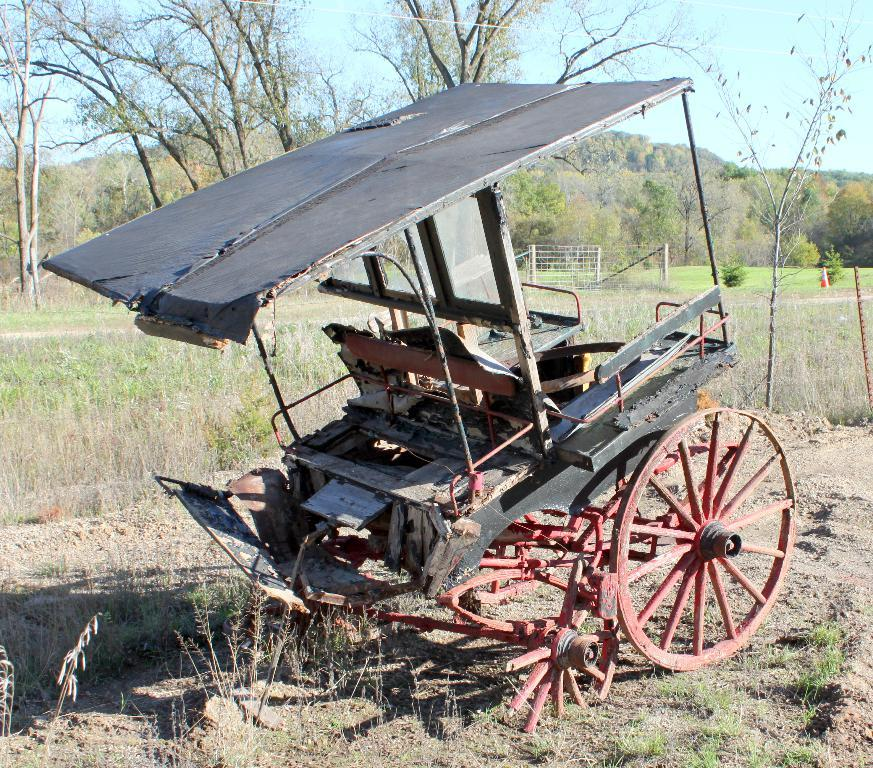What is the main object in the foreground of the image? There is a cart on grass in the image. What can be seen in the background of the image? In the background, there are plants, a fence, trees, mountains, and the sky. What type of environment might the image depict? The image may have been taken in a farm, given the presence of grass and the cart. What type of system is being used to wage war in the image? There is no indication of war or any system being used for that purpose in the image. 